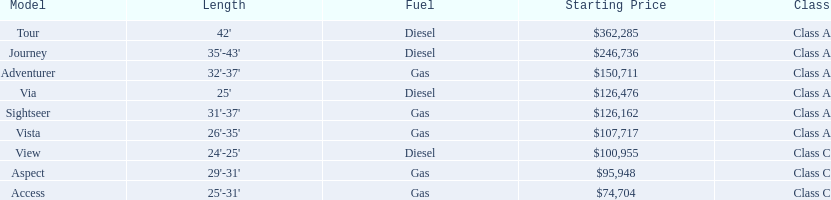Which model has the lowest starting price? Access. Which model has the second most highest starting price? Journey. Which model has the highest price in the winnebago industry? Tour. 